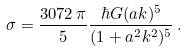Convert formula to latex. <formula><loc_0><loc_0><loc_500><loc_500>\sigma = \frac { 3 0 7 2 \, \pi } { 5 } \frac { \hbar { G } ( a k ) ^ { 5 } } { ( 1 + a ^ { 2 } k ^ { 2 } ) ^ { 5 } } \, .</formula> 